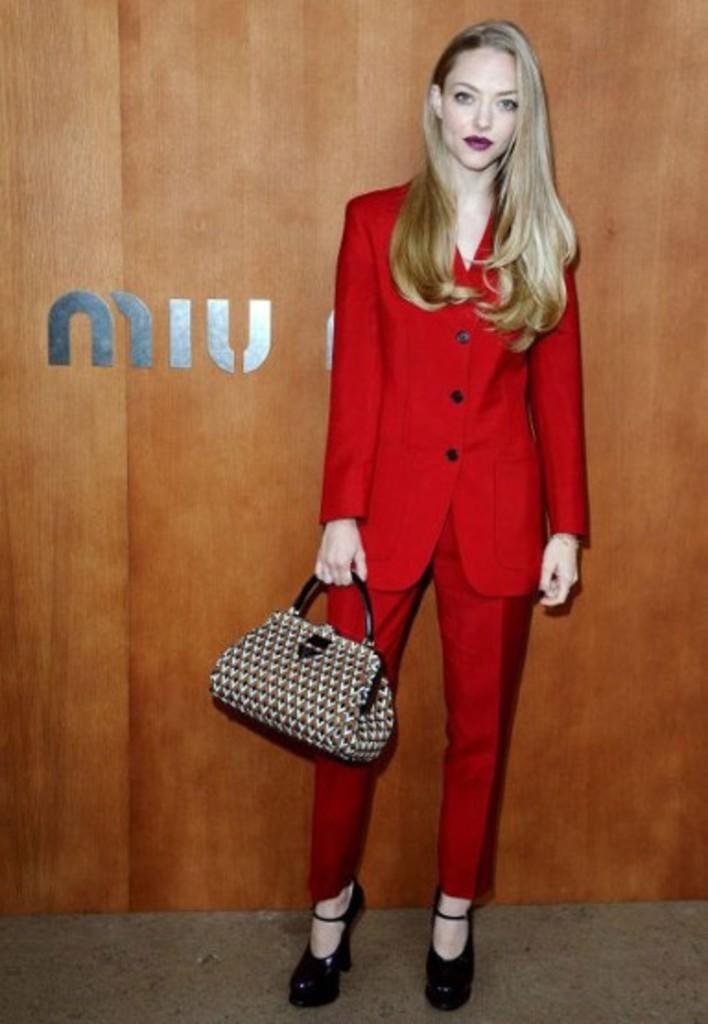In one or two sentences, can you explain what this image depicts? In this image there is a woman wearing a red color blazer, catching a leather handbag in her hand, standing near a board. 